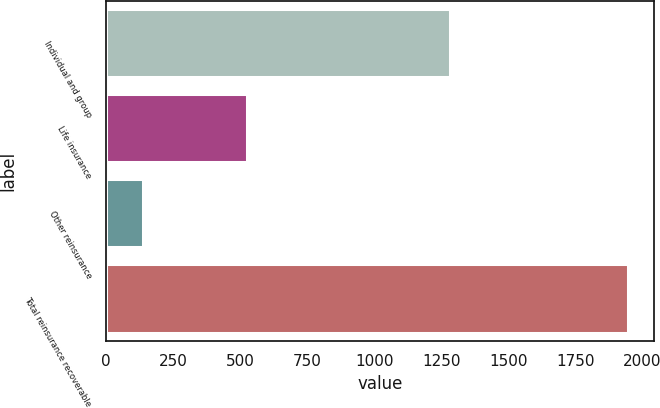Convert chart to OTSL. <chart><loc_0><loc_0><loc_500><loc_500><bar_chart><fcel>Individual and group<fcel>Life insurance<fcel>Other reinsurance<fcel>Total reinsurance recoverable<nl><fcel>1283<fcel>524<fcel>139<fcel>1946<nl></chart> 